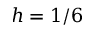<formula> <loc_0><loc_0><loc_500><loc_500>h = 1 / 6</formula> 